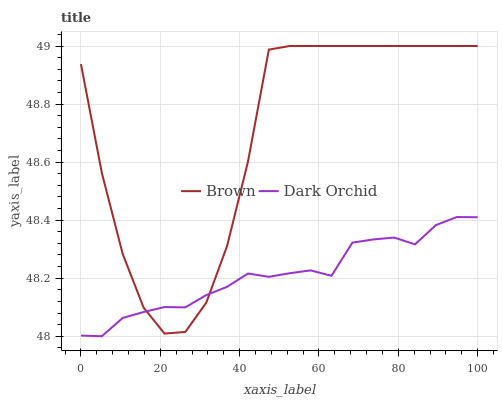Does Dark Orchid have the minimum area under the curve?
Answer yes or no. Yes. Does Brown have the maximum area under the curve?
Answer yes or no. Yes. Does Dark Orchid have the maximum area under the curve?
Answer yes or no. No. Is Dark Orchid the smoothest?
Answer yes or no. Yes. Is Brown the roughest?
Answer yes or no. Yes. Is Dark Orchid the roughest?
Answer yes or no. No. Does Dark Orchid have the lowest value?
Answer yes or no. Yes. Does Brown have the highest value?
Answer yes or no. Yes. Does Dark Orchid have the highest value?
Answer yes or no. No. Does Dark Orchid intersect Brown?
Answer yes or no. Yes. Is Dark Orchid less than Brown?
Answer yes or no. No. Is Dark Orchid greater than Brown?
Answer yes or no. No. 